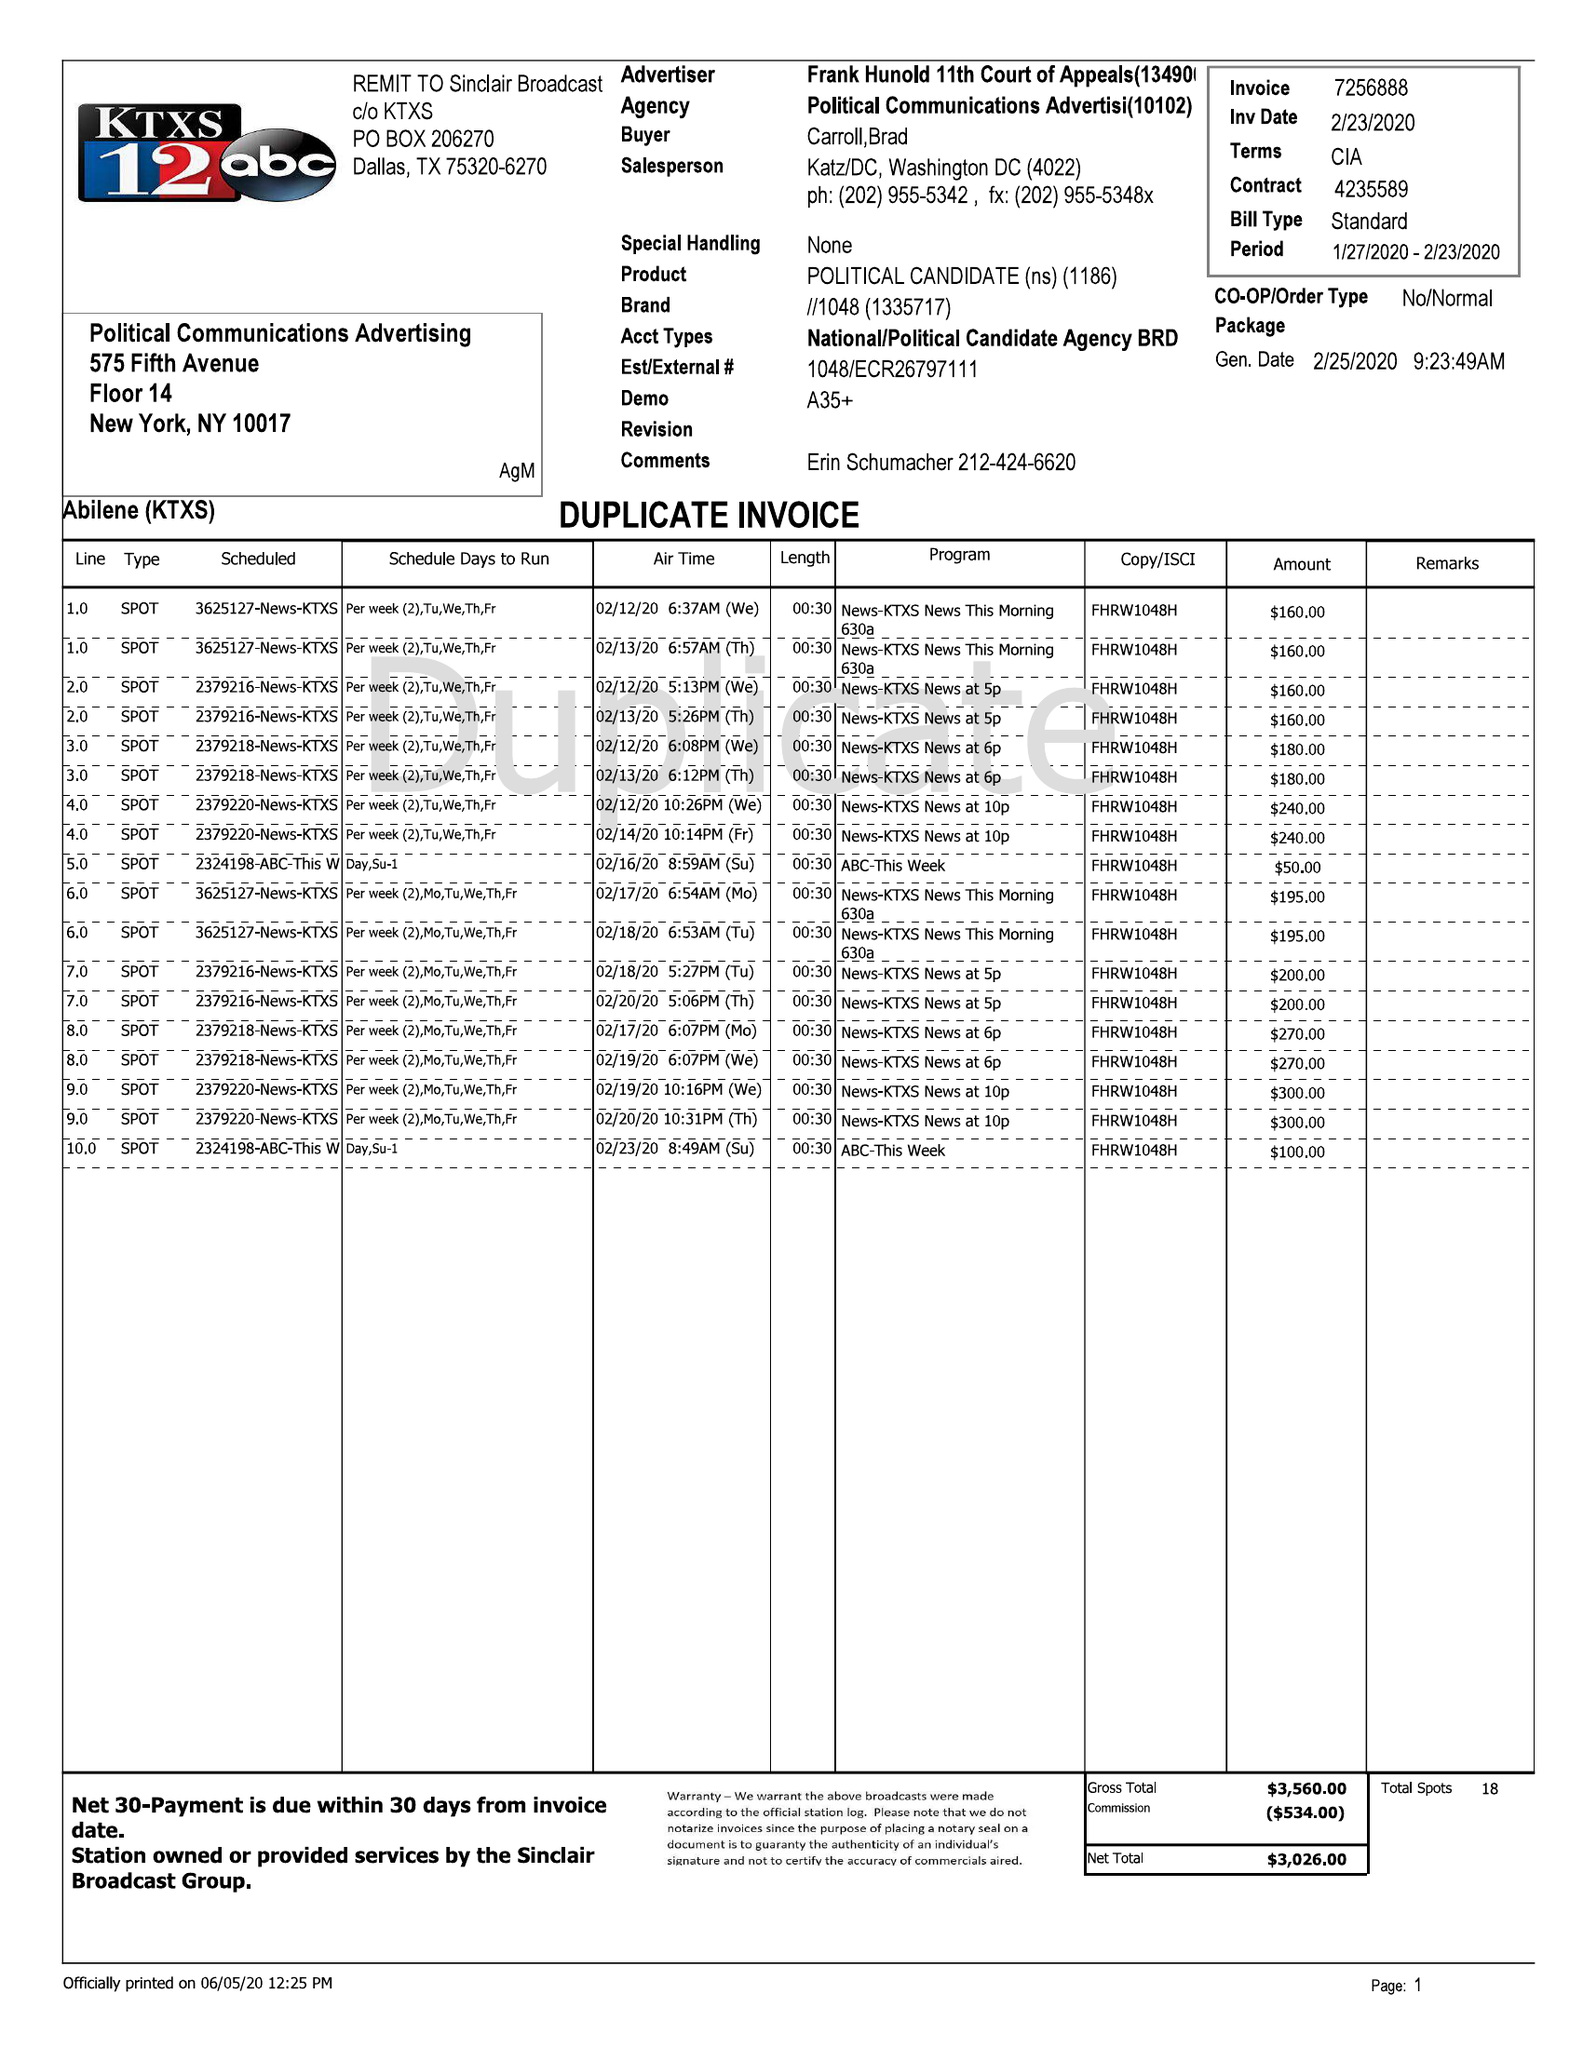What is the value for the flight_from?
Answer the question using a single word or phrase. 01/27/20 